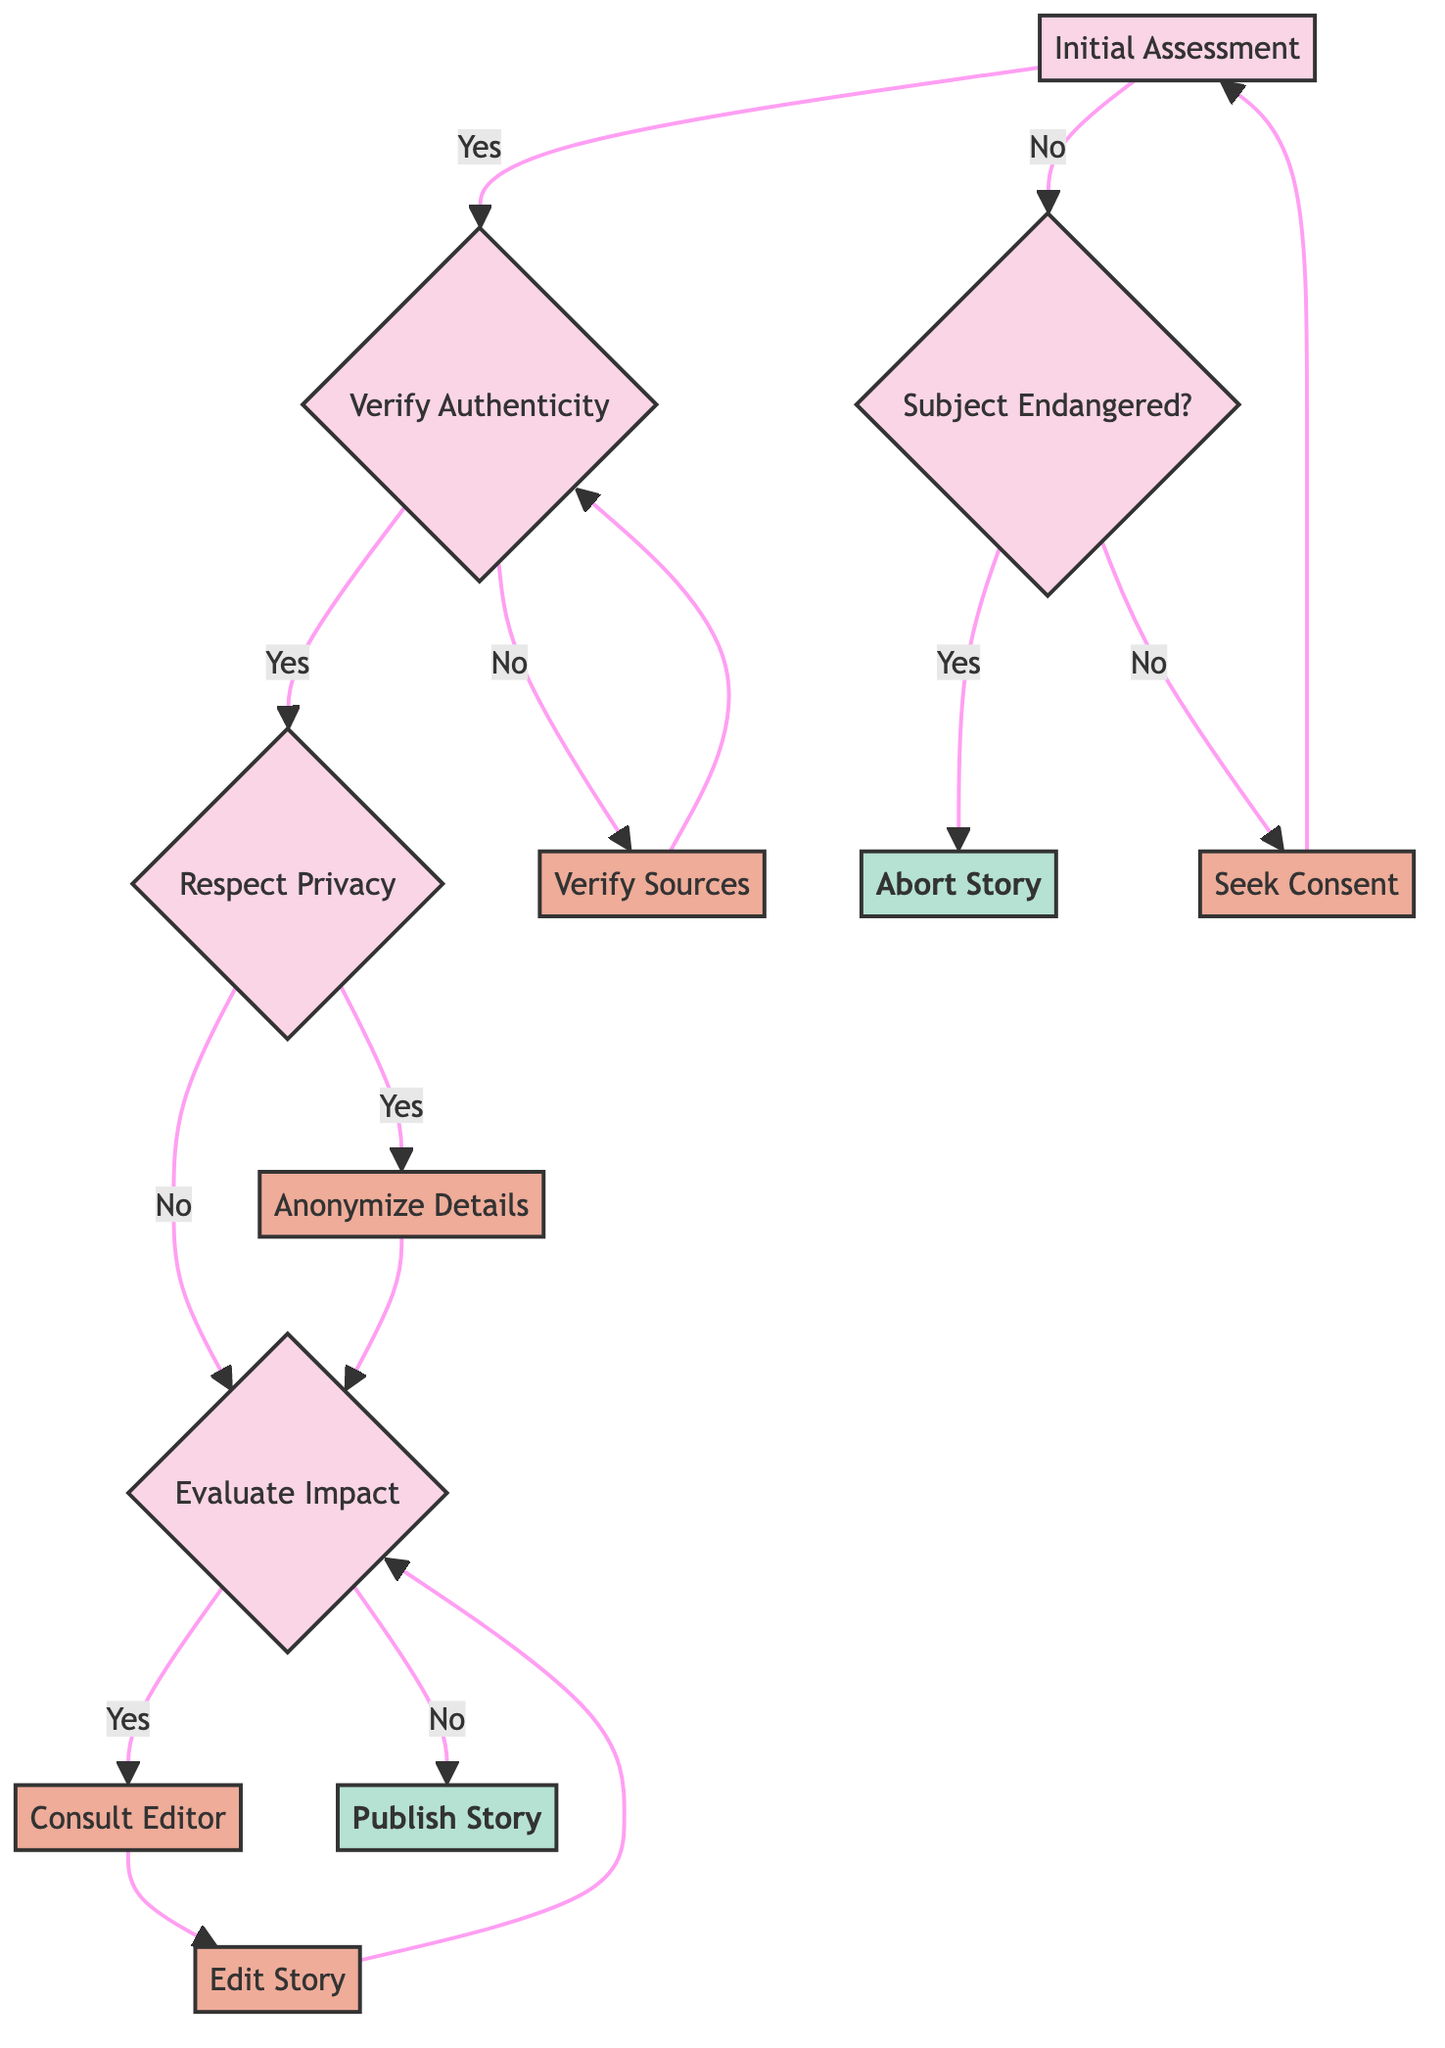What is the first question asked in the decision tree? The first question in the decision tree is located at the "Initial Assessment" node, which asks, "Has the subject given informed consent?"
Answer: Has the subject given informed consent? How many actions are present in the diagram? By reviewing the nodes in the diagram, I can count the total actions listed. The actions are "Seek informed consent from the subject," "Cross-check facts and verify sources," "Anonymize details to protect the subject’s identity," "Consult with the editor to evaluate risk and modify if necessary," "Edit the story to mitigate potential harm," and "Publish the story with necessary safeguards." This totals six actions.
Answer: Six actions What happens if the subject has not given informed consent? The flow shows that if the subject has not given informed consent, the next step is to evaluate if the subject is potentially endangered by reporting. This is indicated by the node "Subject Endangered?"
Answer: Seek Consent or Abort What are the two outcomes after the "Verify Authenticity" node? The outcomes following the "Verify Authenticity" node are determined by whether the authenticity of the story has been verified. If yes, it leads to "Respect Privacy;" if no, it leads to "Verify Sources."
Answer: Respect Privacy and Verify Sources What is the action taken if identifiable details could breach privacy? If there are identifiable details that could breach privacy, the action taken is to "Anonymize details to protect the subject’s identity," as indicated in the flow of the diagram.
Answer: Anonymize details If the story could cause harm, what should be done next? If the evaluation indicates that the story could cause harm to the subject or others, the next action is to "Consult with the editor to evaluate risk and modify if necessary," as indicated in the decision tree's flow.
Answer: Consult with the editor What is the end action if the story can be published? If it is determined that the story can be published with necessary safeguards, the end action is to "Publish the story," concluding that branch of the decision tree.
Answer: Publish the story What is the decision-making process about the story if the subject is endangered? If it's determined that the subject is potentially endangered by reporting, the decision is to "Abort the story" to protect the subject, according to the decision tree structure.
Answer: Abort Story What happens after consulting with the editor? After consulting with the editor, the next action is to "Edit the story to mitigate potential harm," as indicated in the flow that leads from consulting the editor.
Answer: Edit the story 